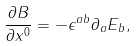Convert formula to latex. <formula><loc_0><loc_0><loc_500><loc_500>\frac { \partial B } { \partial x ^ { 0 } } = - \epsilon ^ { a b } \partial _ { a } E _ { b } ,</formula> 